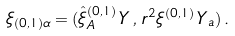Convert formula to latex. <formula><loc_0><loc_0><loc_500><loc_500>\xi _ { ( 0 , 1 ) \alpha } = ( \hat { \xi } _ { A } ^ { ( 0 , 1 ) } \, Y \, , \, r ^ { 2 } \xi ^ { ( 0 , 1 ) } \, Y _ { a } ) \, .</formula> 